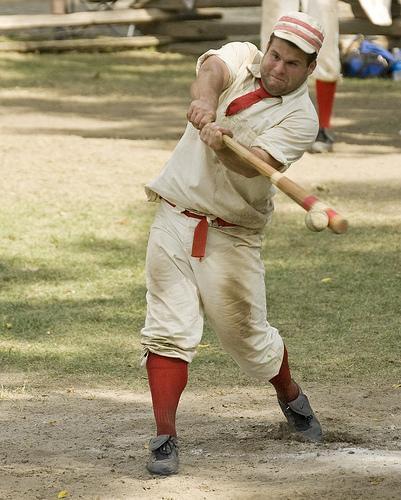How many batters are there?
Give a very brief answer. 1. 